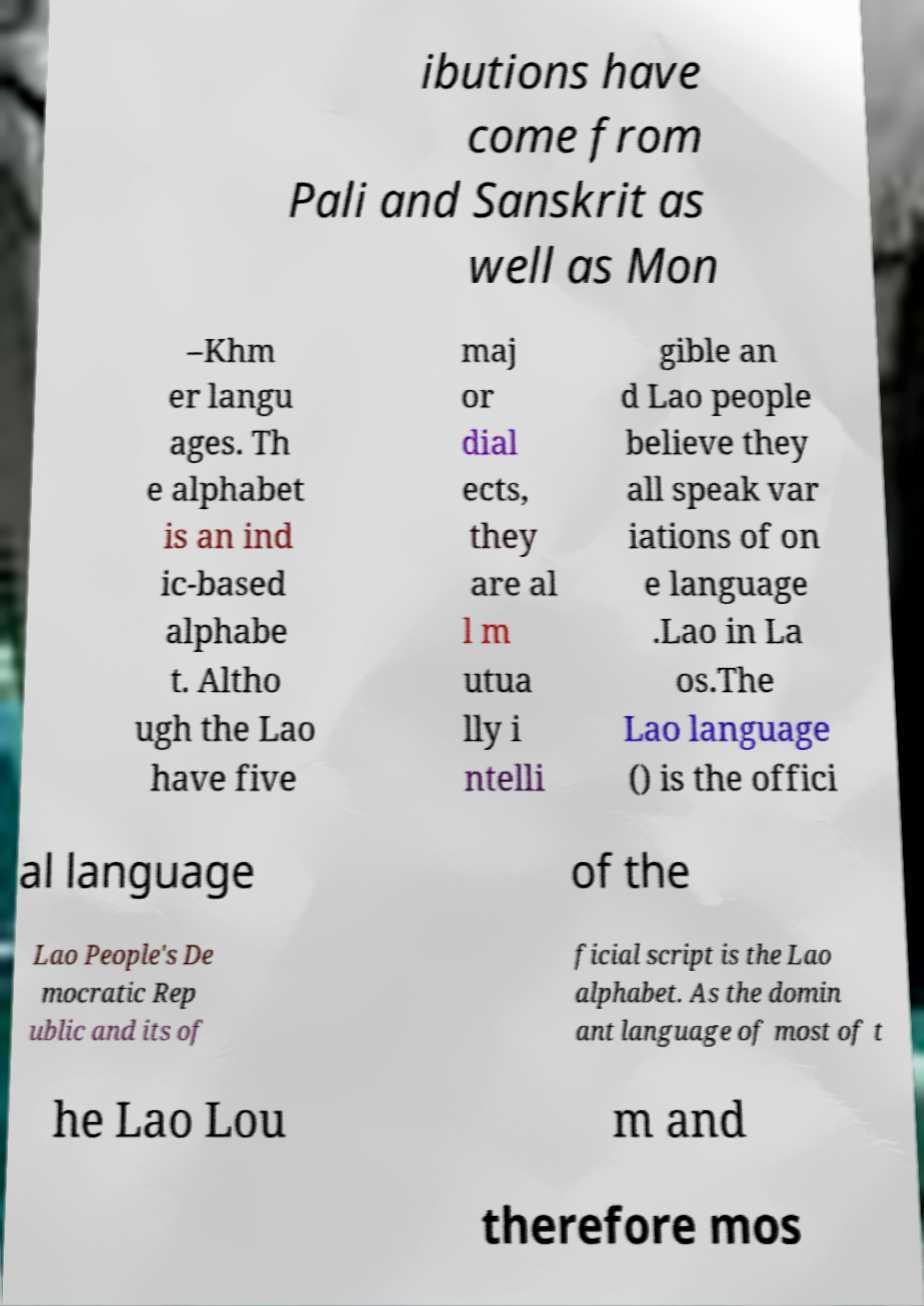Please identify and transcribe the text found in this image. ibutions have come from Pali and Sanskrit as well as Mon –Khm er langu ages. Th e alphabet is an ind ic-based alphabe t. Altho ugh the Lao have five maj or dial ects, they are al l m utua lly i ntelli gible an d Lao people believe they all speak var iations of on e language .Lao in La os.The Lao language () is the offici al language of the Lao People's De mocratic Rep ublic and its of ficial script is the Lao alphabet. As the domin ant language of most of t he Lao Lou m and therefore mos 